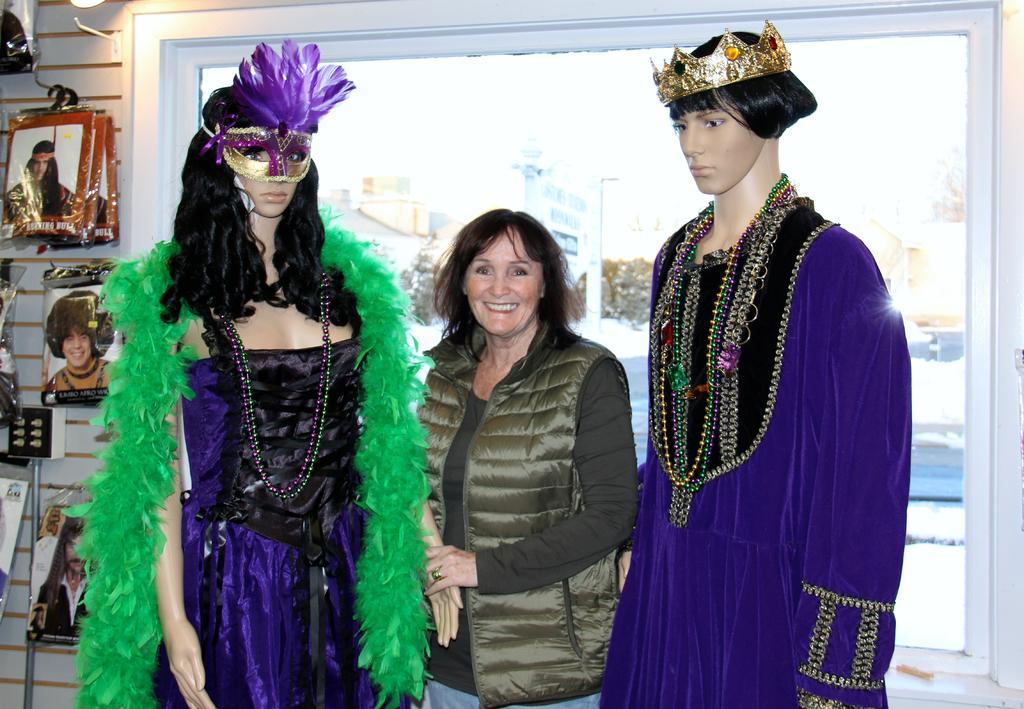Could you give a brief overview of what you see in this image? In the center of the image we can see a lady standing and smiling. There are mannequins we can see clothes on it. On the left we can see things placed on the wall and there is a window. we can see a light. 